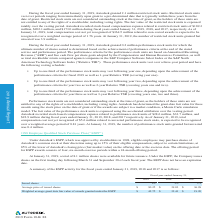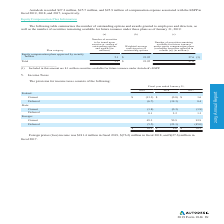According to Autodesk's financial document, How many restricted stock units did Autodesk grant in the fiscal year ended 31 January, 2019? According to the financial document, 2.1 million. The relevant text states: "cal year ended January 31, 2019, Autodesk granted 2.1 million restricted stock units. Restricted stock units vest over periods ranging from immediately upon gran..." Also, What is the performance criteria for the performance stock units? The performance criteria for the performance stock units are based on Annualized Recurring Revenue ("ARR") and free cash flow per share goals adopted by the Compensation and Human Resources Committee, as well as total stockholder return compared against companies in the S&P Computer Software Select Index or the S&P North American Technology Software Index ("Relative TSR").. The document states: "end of the stated service and performance period. The performance criteria for the performance stock units are based on Annualized Recurring Revenue (..." Also, How many units of unvested restricted stock were there as of January 31, 2019? Based on the financial document, the answer is 4,287.4 (in thousands). Also, can you calculate: What is the difference in the units of unvested restricted stock for 2019 and 2018? Based on the calculation: 5,670.7-4,287.4, the result is 1383.3 (in thousands). The key data points involved are: 4,287.4, 5,670.7. Also, can you calculate: What is the average fair value of the shares vested for the period from 2017 to 2019? To answer this question, I need to perform calculations using the financial data. The calculation is: (425.4+399.7+232.2)/3, which equals 352.43 (in millions). The key data points involved are: 232.2, 399.7, 425.4. Also, can you calculate: What is the average fair value of the shares vested for the period from 2017 to 2019?? To answer this question, I need to perform calculations using the financial data. The calculation is: (425.4+399.7+232.2)/3 , which equals 352.43 (in millions). The key data points involved are: 232.2, 399.7, 425.4. 